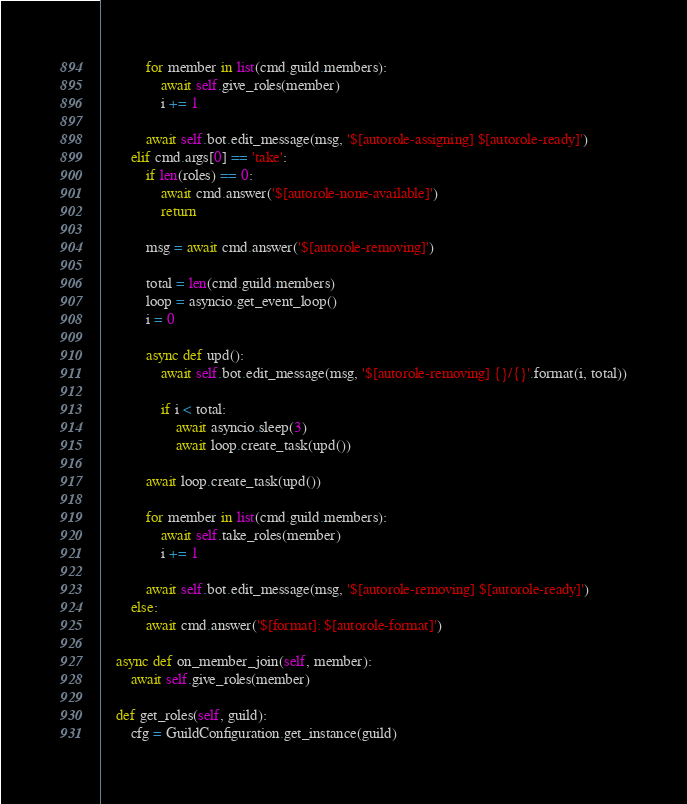<code> <loc_0><loc_0><loc_500><loc_500><_Python_>
            for member in list(cmd.guild.members):
                await self.give_roles(member)
                i += 1

            await self.bot.edit_message(msg, '$[autorole-assigning] $[autorole-ready]')
        elif cmd.args[0] == 'take':
            if len(roles) == 0:
                await cmd.answer('$[autorole-none-available]')
                return

            msg = await cmd.answer('$[autorole-removing]')

            total = len(cmd.guild.members)
            loop = asyncio.get_event_loop()
            i = 0

            async def upd():
                await self.bot.edit_message(msg, '$[autorole-removing] {}/{}'.format(i, total))

                if i < total:
                    await asyncio.sleep(3)
                    await loop.create_task(upd())

            await loop.create_task(upd())

            for member in list(cmd.guild.members):
                await self.take_roles(member)
                i += 1

            await self.bot.edit_message(msg, '$[autorole-removing] $[autorole-ready]')
        else:
            await cmd.answer('$[format]: $[autorole-format]')

    async def on_member_join(self, member):
        await self.give_roles(member)

    def get_roles(self, guild):
        cfg = GuildConfiguration.get_instance(guild)</code> 